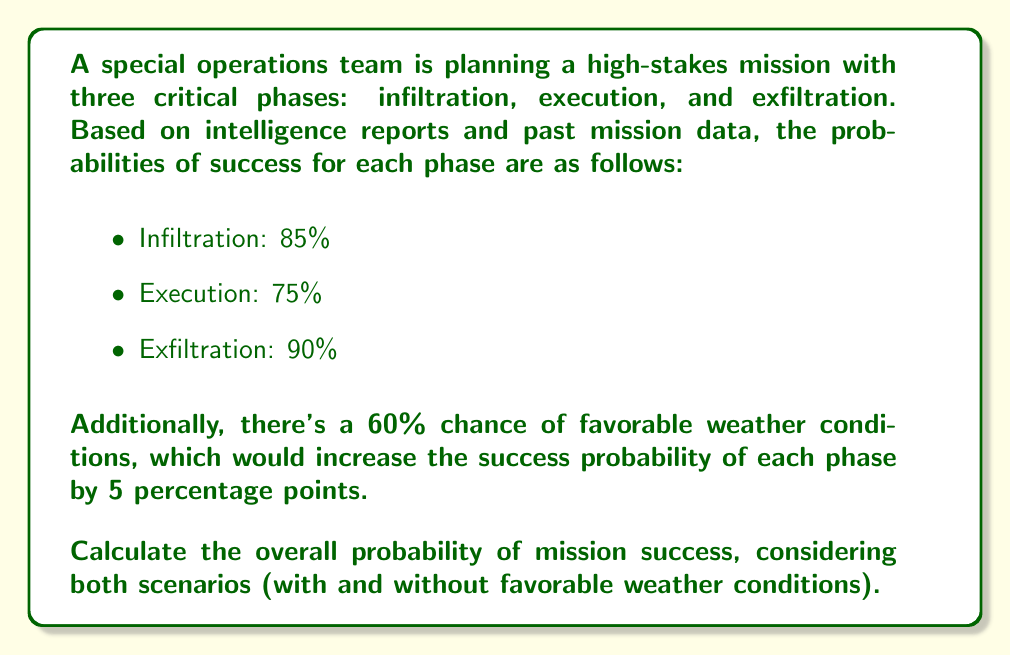What is the answer to this math problem? Let's approach this step-by-step:

1) First, we need to calculate the probability of success for each scenario (with and without favorable weather).

2) Without favorable weather (40% chance):
   - Infiltration: 85%
   - Execution: 75%
   - Exfiltration: 90%

   Overall success probability = $0.85 \times 0.75 \times 0.90 = 0.57375$ or 57.375%

3) With favorable weather (60% chance):
   - Infiltration: 90%
   - Execution: 80%
   - Exfiltration: 95%

   Overall success probability = $0.90 \times 0.80 \times 0.95 = 0.684$ or 68.4%

4) Now, we can use the law of total probability to combine these scenarios:

   $P(\text{Success}) = P(\text{Success}|\text{Unfavorable}) \times P(\text{Unfavorable}) + P(\text{Success}|\text{Favorable}) \times P(\text{Favorable})$

   $P(\text{Success}) = 0.57375 \times 0.40 + 0.684 \times 0.60$

5) Let's calculate:
   $P(\text{Success}) = 0.2295 + 0.4104 = 0.6399$

6) Convert to percentage:
   $0.6399 \times 100\% = 63.99\%$

Therefore, the overall probability of mission success is approximately 63.99%.
Answer: 63.99% 